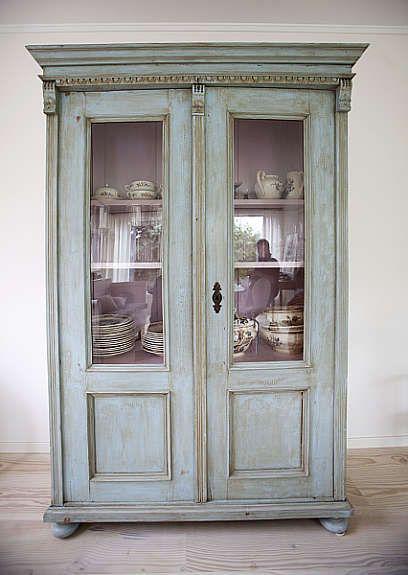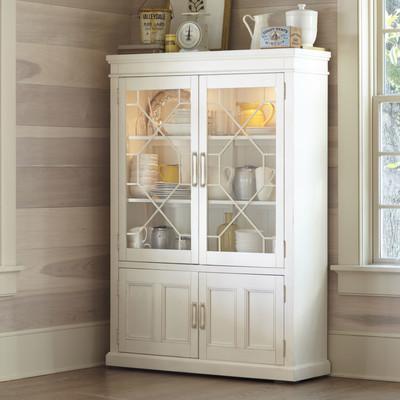The first image is the image on the left, the second image is the image on the right. For the images displayed, is the sentence "The cabinet on the right is set up against a pink wall." factually correct? Answer yes or no. No. The first image is the image on the left, the second image is the image on the right. For the images shown, is this caption "One wooden hutch has a pair of doors and flat top, while the other has a single centered glass door and rounded decorative detail at the top." true? Answer yes or no. No. 